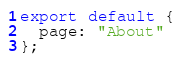<code> <loc_0><loc_0><loc_500><loc_500><_JavaScript_>export default {
  page: "About"
};
</code> 